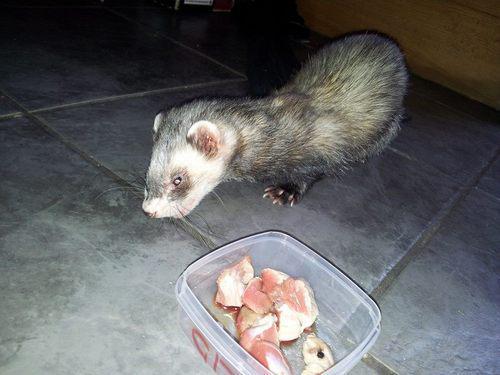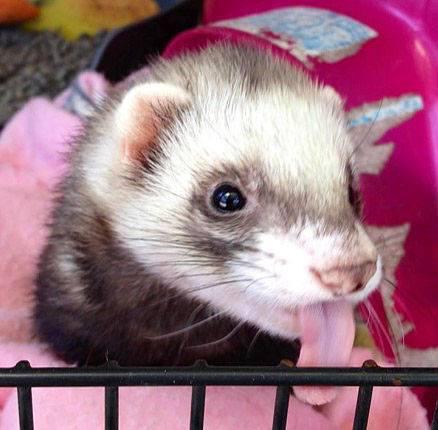The first image is the image on the left, the second image is the image on the right. Evaluate the accuracy of this statement regarding the images: "Someone is offering a ferret a piece of raw meat in at least one image.". Is it true? Answer yes or no. No. The first image is the image on the left, the second image is the image on the right. For the images displayed, is the sentence "The left and right image contains the same number of ferrits with at least one person hand in one image." factually correct? Answer yes or no. No. 